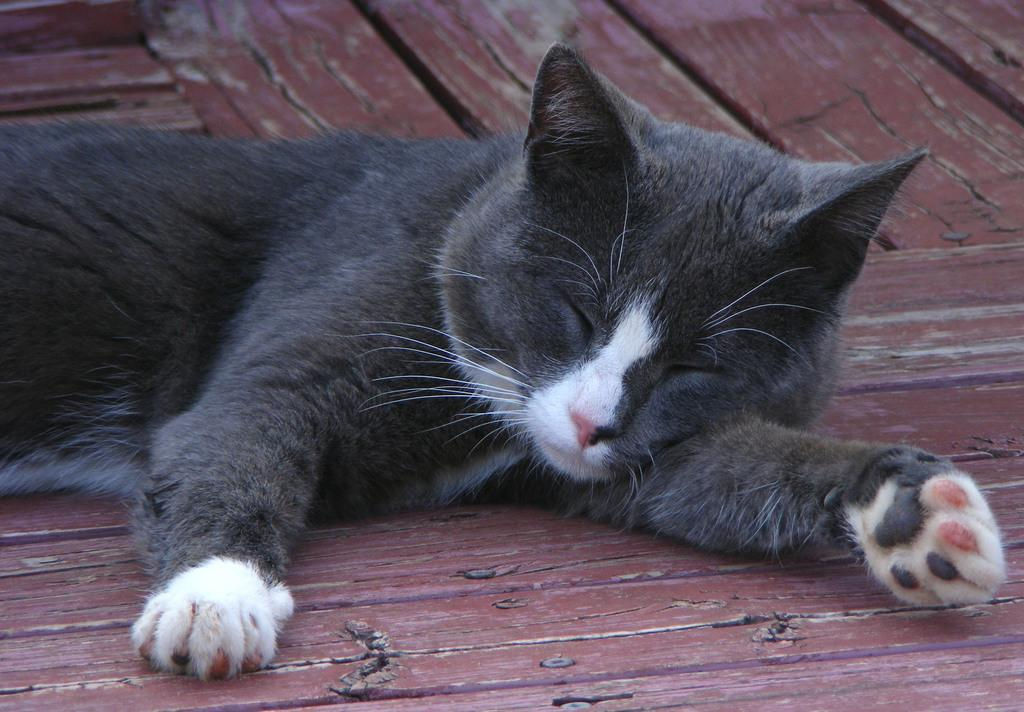What animal is present in the image? There is a cat in the image. Where is the cat located? The cat is on a wooden platform. What type of whistle can be heard in the image? There is no whistle present in the image, as it features a cat on a wooden platform. 